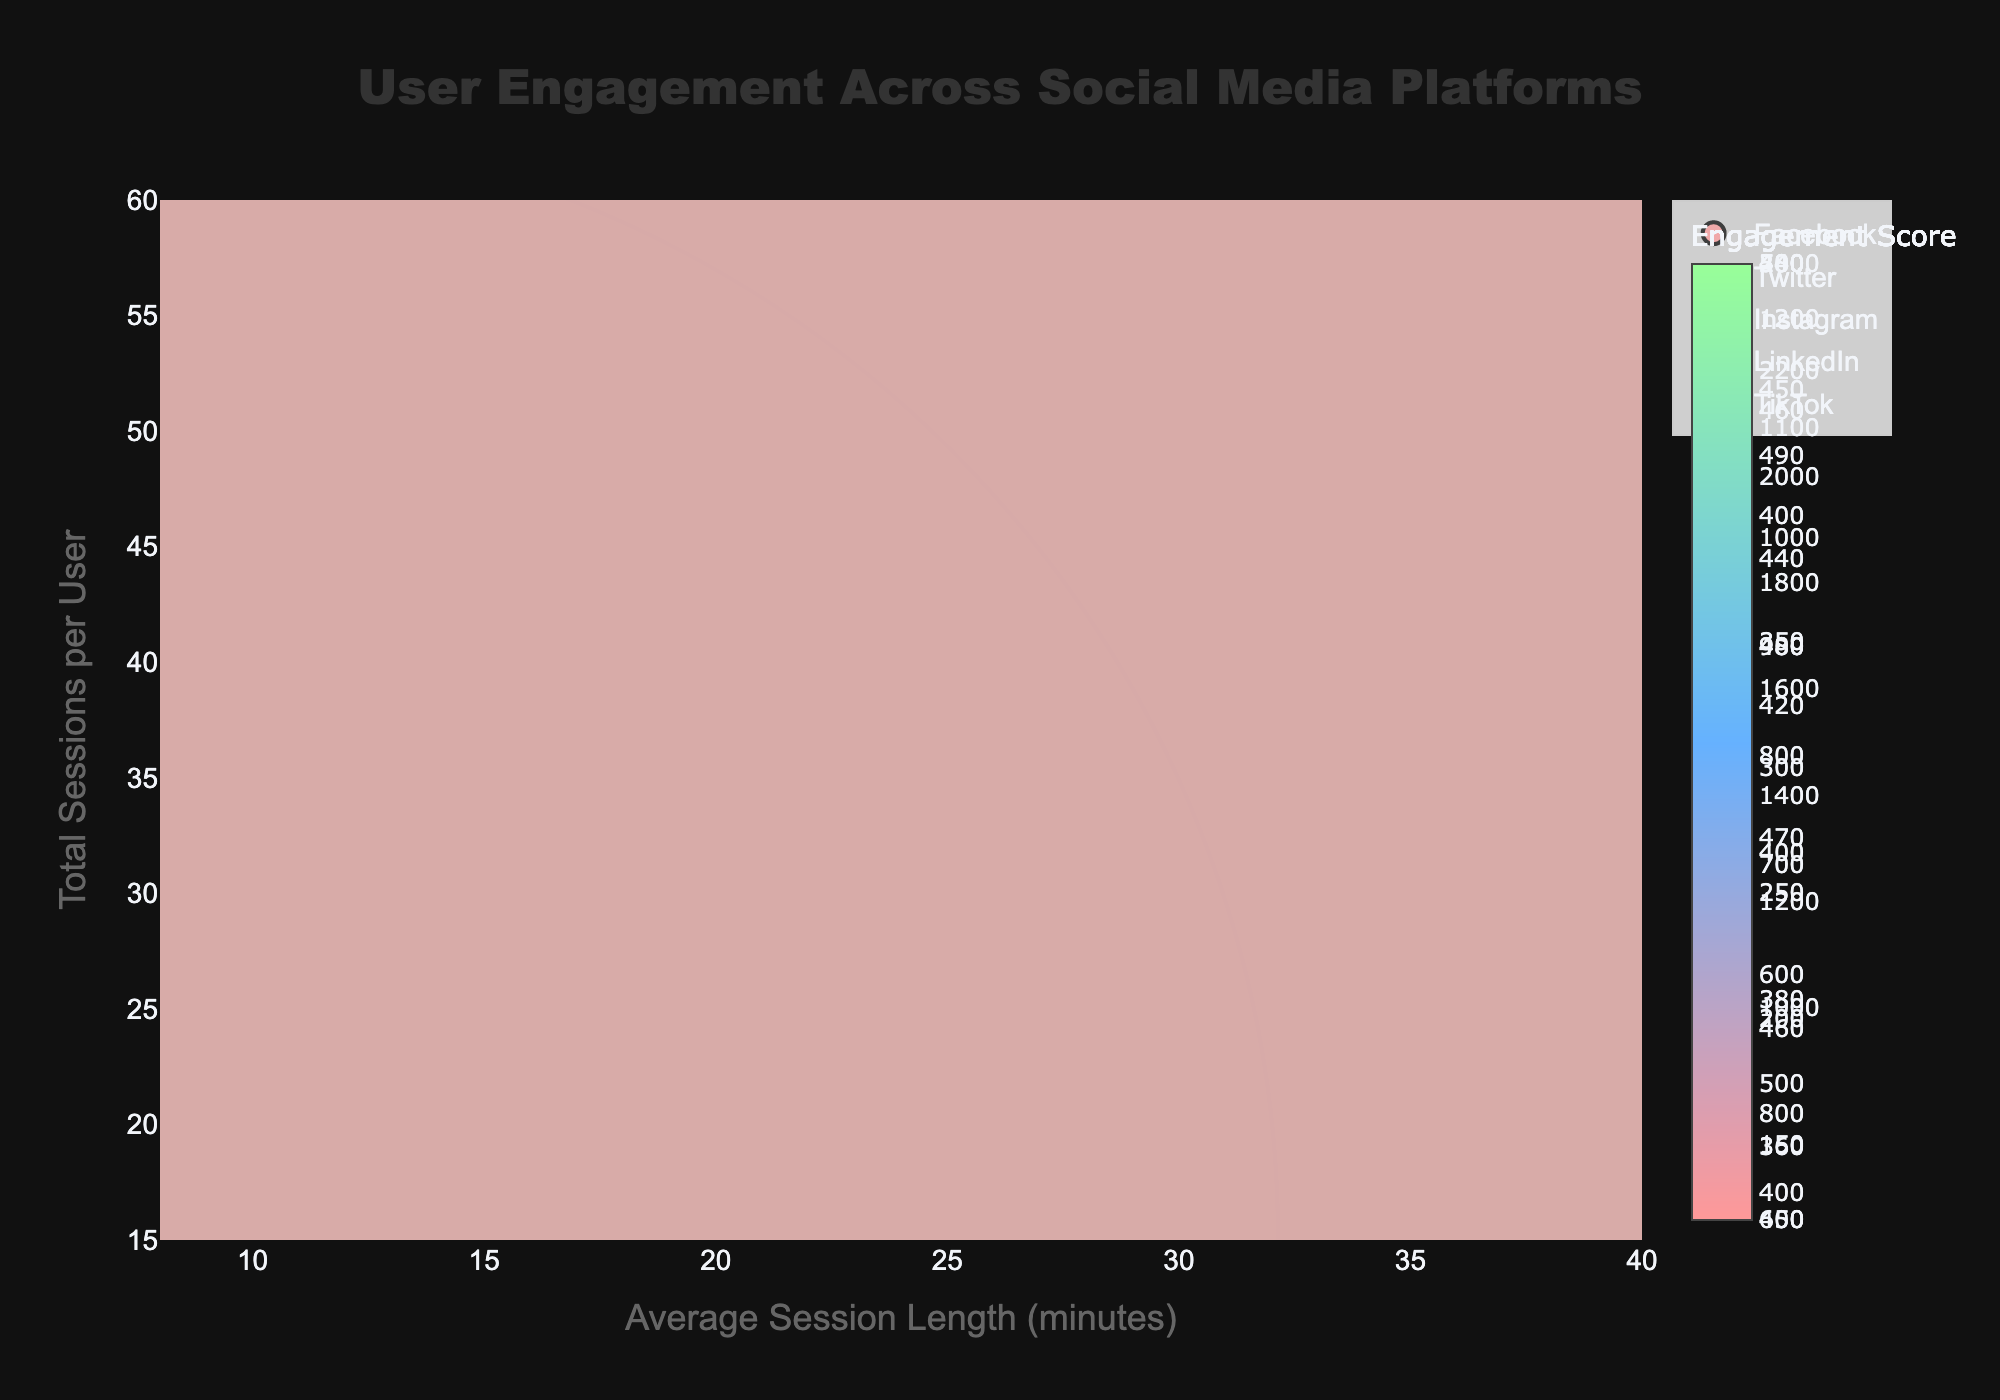What's the title of the figure? The title is typically placed at the top center of a chart. In this bubble chart, it reads 'User Engagement Across Social Media Platforms'.
Answer: User Engagement Across Social Media Platforms Which demographic group has the highest engagement score on TikTok? Look for the bubble associated with TikTok and check the hover text or size, color intensity of the bubbles. The demographic group with the highest engagement score is 18-24.
Answer: 18-24 What is the average session length for Instagram users aged 25-34? Hover over or locate the bubbles representing Instagram, identify the 25-34 demographic, and read the X-axis value. The average session length is 20 minutes.
Answer: 20 minutes How does the engagement score for Facebook users aged 35-44 compare to LinkedIn users aged 35-44? Compare the color intensity or hover over the specific bubbles for Facebook and LinkedIn corresponding to the 35-44 age group. Both have an engagement score of 500.
Answer: They are equal (500) Which platform has the largest bubble, and what does it signify? Identify the largest bubble by size and color intensity. The largest bubble represents TikTok for the 18-24 demographic, indicating the highest engagement score.
Answer: TikTok (18-24) What is the total number of bubbles (data points) in the chart? Count each bubble plotted on the bubble chart, representing different demographic groups across platforms. There are 15 bubbles.
Answer: 15 What's the average engagement score across all platforms for the 25-34 demographic? Sum the engagement scores for the 25-34 demographic across all platforms: 500 (Facebook) + 350 (Twitter) + 800 (Instagram) + 300 (LinkedIn) + 1750 (TikTok) = 3700. Divide by the number of platforms, 5.
Answer: 740 Which platform and demographic combination have the shortest average session length? Identify the shortest average session length on the X-axis and hover over or check the bubble representing that value, which is LinkedIn for 18-24 years old with 8 minutes.
Answer: LinkedIn (18-24) What is the engagement score difference between the 18-24 and 35-44 age groups on Instagram? Check the engagement scores for the 18-24 (1250) and 35-44 (375) age groups on Instagram. Calculate the difference: 1250 - 375.
Answer: 875 On which platform do users aged 25-34 have the highest number of total sessions per user? Find the bubbles representing the 25-34 demographic and compare their Y-axis values across all platforms. TikTok has the highest total sessions per user at 50.
Answer: TikTok 